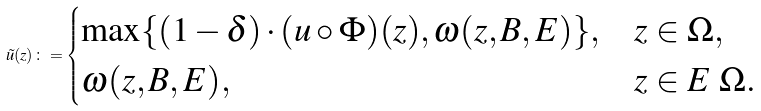Convert formula to latex. <formula><loc_0><loc_0><loc_500><loc_500>\tilde { u } ( z ) \colon = \begin{cases} \max \{ ( 1 - \delta ) \cdot ( u \circ \Phi ) ( z ) , \omega ( z , B , E ) \} , & z \in \Omega , \\ \omega ( z , B , E ) , & z \in E \ \Omega . \end{cases}</formula> 